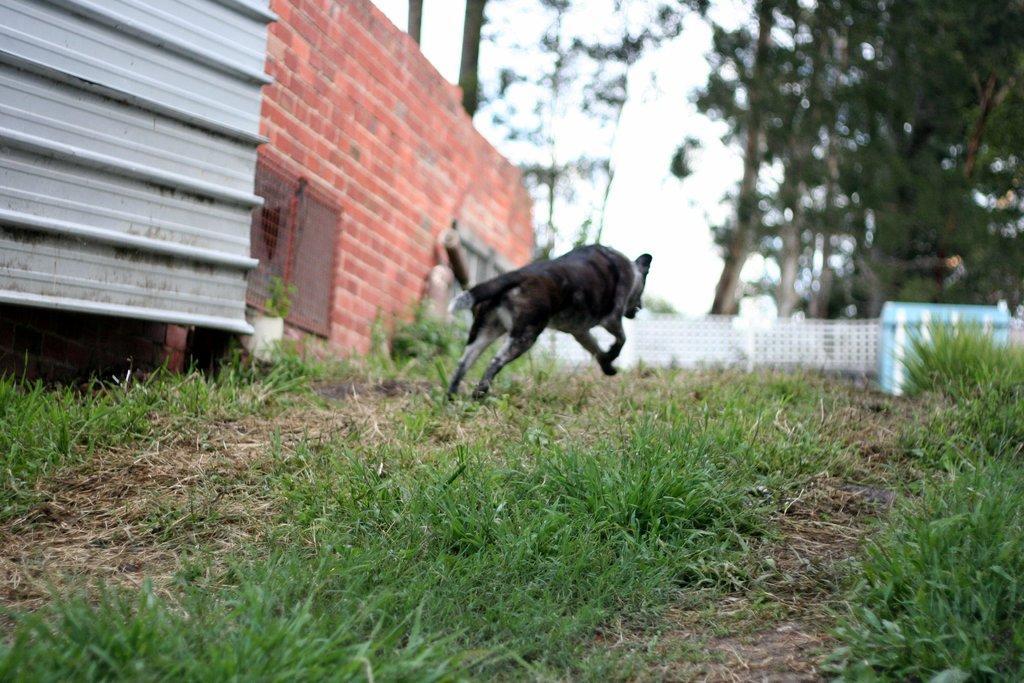Describe this image in one or two sentences. At the bottom of the image on the ground there is grass. There is a dog running. And on the left side of the image there is a wall with windows. In the background there is fencing. Behind the fencing there are trees. 